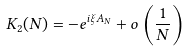Convert formula to latex. <formula><loc_0><loc_0><loc_500><loc_500>K _ { 2 } ( N ) = - e ^ { i \xi A _ { N } } + o \left ( \frac { 1 } { N } \right )</formula> 